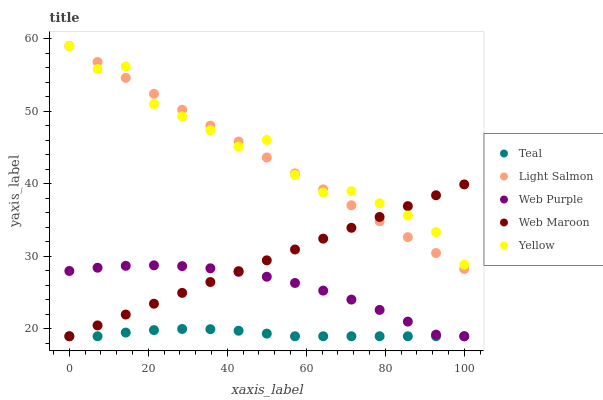Does Teal have the minimum area under the curve?
Answer yes or no. Yes. Does Yellow have the maximum area under the curve?
Answer yes or no. Yes. Does Web Maroon have the minimum area under the curve?
Answer yes or no. No. Does Web Maroon have the maximum area under the curve?
Answer yes or no. No. Is Light Salmon the smoothest?
Answer yes or no. Yes. Is Yellow the roughest?
Answer yes or no. Yes. Is Web Maroon the smoothest?
Answer yes or no. No. Is Web Maroon the roughest?
Answer yes or no. No. Does Web Maroon have the lowest value?
Answer yes or no. Yes. Does Yellow have the lowest value?
Answer yes or no. No. Does Yellow have the highest value?
Answer yes or no. Yes. Does Web Maroon have the highest value?
Answer yes or no. No. Is Teal less than Yellow?
Answer yes or no. Yes. Is Yellow greater than Teal?
Answer yes or no. Yes. Does Web Maroon intersect Light Salmon?
Answer yes or no. Yes. Is Web Maroon less than Light Salmon?
Answer yes or no. No. Is Web Maroon greater than Light Salmon?
Answer yes or no. No. Does Teal intersect Yellow?
Answer yes or no. No. 